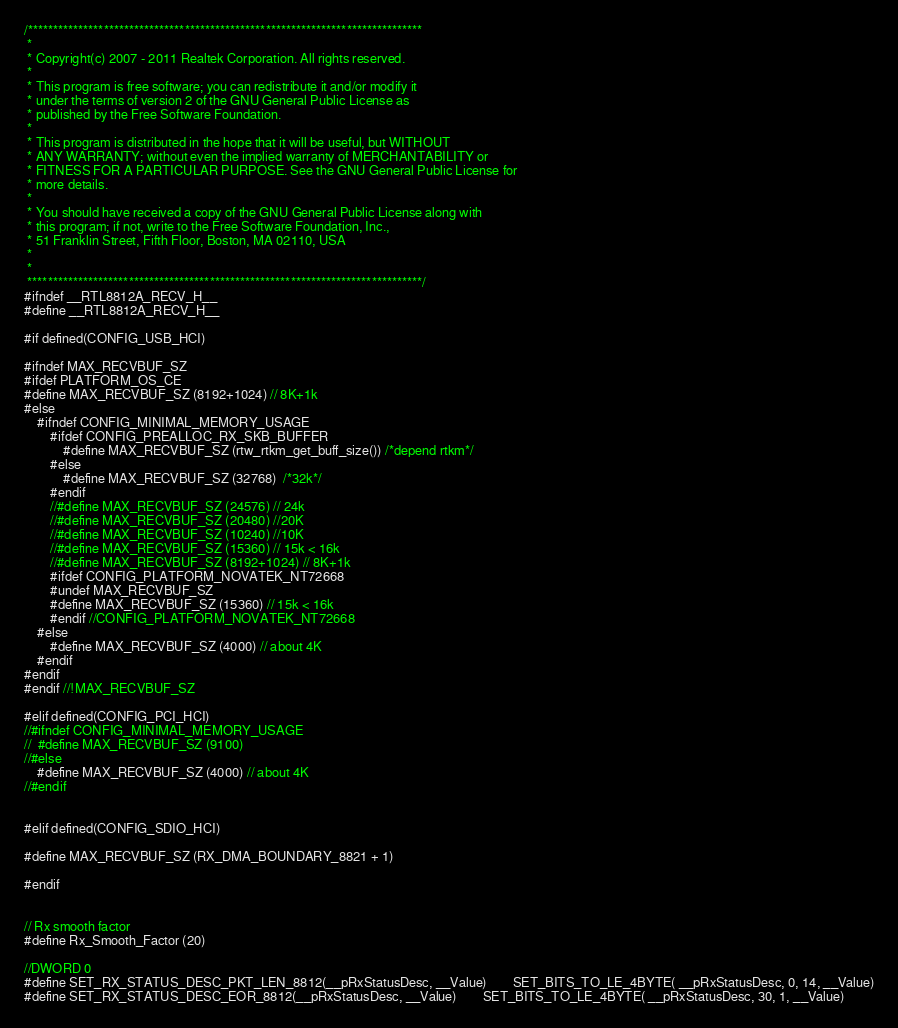Convert code to text. <code><loc_0><loc_0><loc_500><loc_500><_C_>/******************************************************************************
 *
 * Copyright(c) 2007 - 2011 Realtek Corporation. All rights reserved.
 *
 * This program is free software; you can redistribute it and/or modify it
 * under the terms of version 2 of the GNU General Public License as
 * published by the Free Software Foundation.
 *
 * This program is distributed in the hope that it will be useful, but WITHOUT
 * ANY WARRANTY; without even the implied warranty of MERCHANTABILITY or
 * FITNESS FOR A PARTICULAR PURPOSE. See the GNU General Public License for
 * more details.
 *
 * You should have received a copy of the GNU General Public License along with
 * this program; if not, write to the Free Software Foundation, Inc.,
 * 51 Franklin Street, Fifth Floor, Boston, MA 02110, USA
 *
 *
 ******************************************************************************/
#ifndef __RTL8812A_RECV_H__
#define __RTL8812A_RECV_H__

#if defined(CONFIG_USB_HCI)

#ifndef MAX_RECVBUF_SZ
#ifdef PLATFORM_OS_CE
#define MAX_RECVBUF_SZ (8192+1024) // 8K+1k
#else
	#ifndef CONFIG_MINIMAL_MEMORY_USAGE
		#ifdef CONFIG_PREALLOC_RX_SKB_BUFFER
			#define MAX_RECVBUF_SZ (rtw_rtkm_get_buff_size()) /*depend rtkm*/
		#else
			#define MAX_RECVBUF_SZ (32768)  /*32k*/
		#endif
		//#define MAX_RECVBUF_SZ (24576) // 24k
		//#define MAX_RECVBUF_SZ (20480) //20K
		//#define MAX_RECVBUF_SZ (10240) //10K
		//#define MAX_RECVBUF_SZ (15360) // 15k < 16k
		//#define MAX_RECVBUF_SZ (8192+1024) // 8K+1k
		#ifdef CONFIG_PLATFORM_NOVATEK_NT72668
		#undef MAX_RECVBUF_SZ
		#define MAX_RECVBUF_SZ (15360) // 15k < 16k
		#endif //CONFIG_PLATFORM_NOVATEK_NT72668
	#else
		#define MAX_RECVBUF_SZ (4000) // about 4K
	#endif
#endif
#endif //!MAX_RECVBUF_SZ

#elif defined(CONFIG_PCI_HCI)
//#ifndef CONFIG_MINIMAL_MEMORY_USAGE
//	#define MAX_RECVBUF_SZ (9100)
//#else
	#define MAX_RECVBUF_SZ (4000) // about 4K
//#endif


#elif defined(CONFIG_SDIO_HCI)

#define MAX_RECVBUF_SZ (RX_DMA_BOUNDARY_8821 + 1)

#endif


// Rx smooth factor
#define Rx_Smooth_Factor (20)

//DWORD 0
#define SET_RX_STATUS_DESC_PKT_LEN_8812(__pRxStatusDesc, __Value)		SET_BITS_TO_LE_4BYTE( __pRxStatusDesc, 0, 14, __Value)
#define SET_RX_STATUS_DESC_EOR_8812(__pRxStatusDesc, __Value)		SET_BITS_TO_LE_4BYTE( __pRxStatusDesc, 30, 1, __Value)</code> 